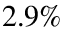<formula> <loc_0><loc_0><loc_500><loc_500>2 . 9 \%</formula> 